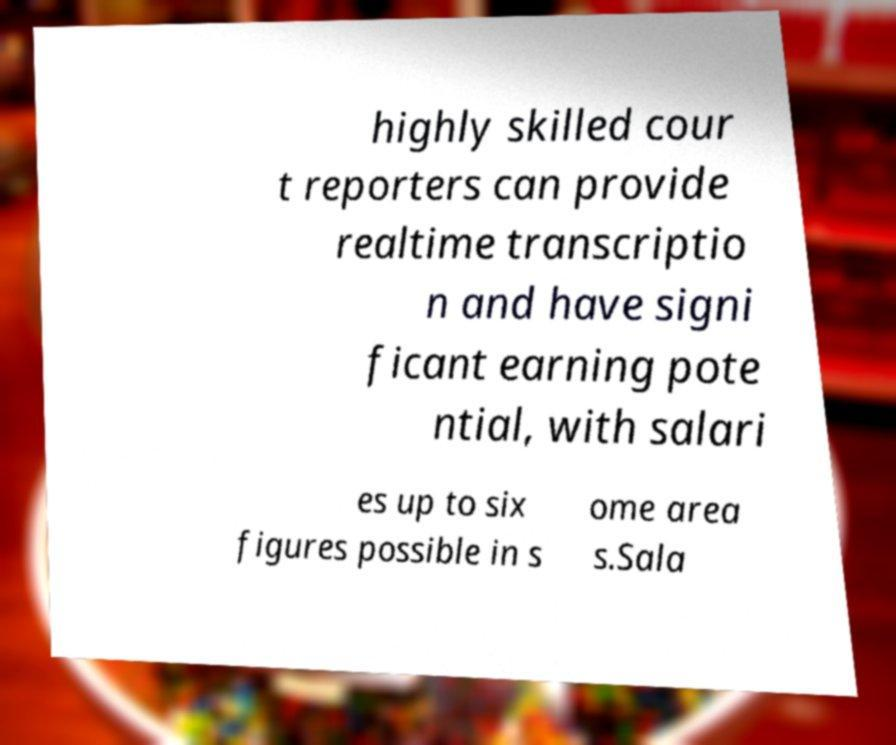For documentation purposes, I need the text within this image transcribed. Could you provide that? highly skilled cour t reporters can provide realtime transcriptio n and have signi ficant earning pote ntial, with salari es up to six figures possible in s ome area s.Sala 